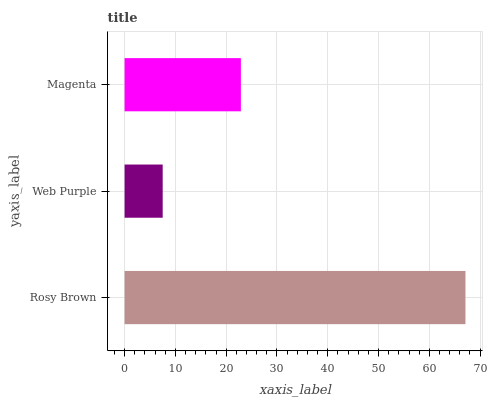Is Web Purple the minimum?
Answer yes or no. Yes. Is Rosy Brown the maximum?
Answer yes or no. Yes. Is Magenta the minimum?
Answer yes or no. No. Is Magenta the maximum?
Answer yes or no. No. Is Magenta greater than Web Purple?
Answer yes or no. Yes. Is Web Purple less than Magenta?
Answer yes or no. Yes. Is Web Purple greater than Magenta?
Answer yes or no. No. Is Magenta less than Web Purple?
Answer yes or no. No. Is Magenta the high median?
Answer yes or no. Yes. Is Magenta the low median?
Answer yes or no. Yes. Is Rosy Brown the high median?
Answer yes or no. No. Is Rosy Brown the low median?
Answer yes or no. No. 